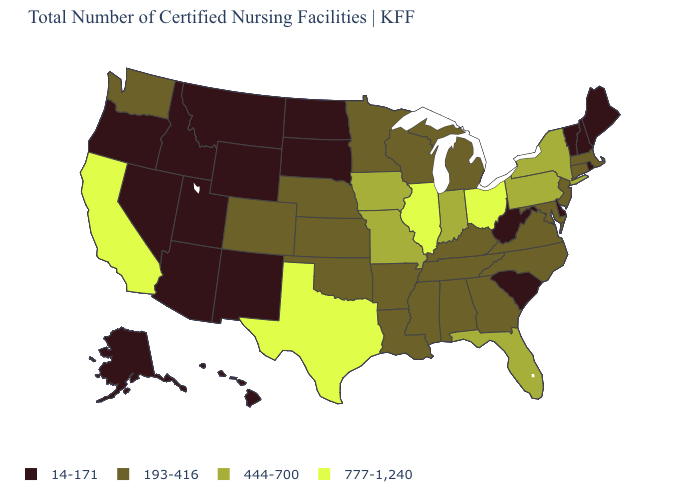Name the states that have a value in the range 444-700?
Write a very short answer. Florida, Indiana, Iowa, Missouri, New York, Pennsylvania. What is the value of California?
Short answer required. 777-1,240. Which states have the highest value in the USA?
Answer briefly. California, Illinois, Ohio, Texas. What is the value of West Virginia?
Short answer required. 14-171. Name the states that have a value in the range 777-1,240?
Concise answer only. California, Illinois, Ohio, Texas. Does Maryland have the lowest value in the USA?
Short answer required. No. What is the value of Pennsylvania?
Be succinct. 444-700. Does Iowa have the same value as Florida?
Be succinct. Yes. Is the legend a continuous bar?
Concise answer only. No. Name the states that have a value in the range 193-416?
Concise answer only. Alabama, Arkansas, Colorado, Connecticut, Georgia, Kansas, Kentucky, Louisiana, Maryland, Massachusetts, Michigan, Minnesota, Mississippi, Nebraska, New Jersey, North Carolina, Oklahoma, Tennessee, Virginia, Washington, Wisconsin. Name the states that have a value in the range 14-171?
Quick response, please. Alaska, Arizona, Delaware, Hawaii, Idaho, Maine, Montana, Nevada, New Hampshire, New Mexico, North Dakota, Oregon, Rhode Island, South Carolina, South Dakota, Utah, Vermont, West Virginia, Wyoming. Does Massachusetts have the highest value in the Northeast?
Write a very short answer. No. Does Wyoming have the highest value in the USA?
Concise answer only. No. Among the states that border Massachusetts , which have the highest value?
Keep it brief. New York. Which states hav the highest value in the West?
Answer briefly. California. 